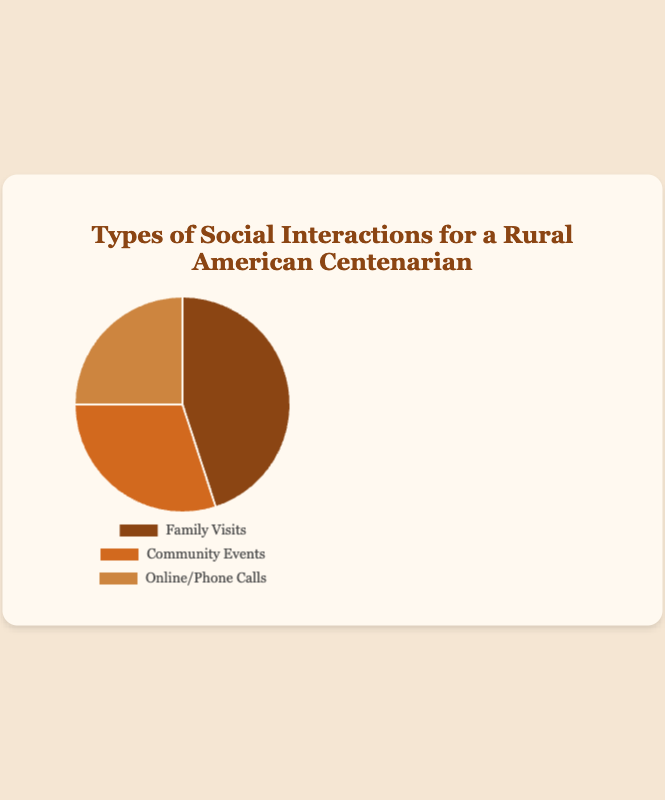Which type of social interaction has the highest percentage? Family Visits has the highest percentage. In the pie chart, Family Visits is shown with the largest segment, representing 45%.
Answer: Family Visits How much more frequent are Family Visits compared to Online/Phone Calls? Family Visits have a percentage of 45, while Online/Phone Calls have a percentage of 25. The difference between them is 45 - 25 = 20%.
Answer: 20% If we add the percentages of Community Events and Online/Phone Calls, what is the total? The percentage for Community Events is 30, and for Online/Phone Calls, it's 25. Adding these together gives 30 + 25 = 55%.
Answer: 55% Which type of social interaction is represented by the smallest section? Online/Phone Calls is represented by the smallest section of the pie, with 25%.
Answer: Online/Phone Calls Are Community Events more or less frequent than Online/Phone Calls? Community Events make up 30% while Online/Phone Calls make up 25%. Community Events are 5% more frequent.
Answer: More By how much does the percentage of Family Visits exceed the combined percentage of Community Events and Online/Phone Calls? Family Visits are 45%, and the combined percentage of Community Events and Online/Phone Calls is 55%. The difference is 45 - 55 = -10%, meaning Family Visits do not exceed but rather are 10% less.
Answer: -10% What fraction of the total social interactions are represented by Community Events? Community Events make up 30% of the total interactions. Converting this to a fraction, 30% is the same as 30/100 or 3/10.
Answer: 3/10 If the total number of social interactions is 100 (assuming percentages as absolute numbers), how many interactions are through Family Visits? If the total number of interactions is 100, and Family Visits are 45%, then the number of Family Visits is 45% of 100, which is (0.45 * 100) = 45 interactions.
Answer: 45 What is the average percentage of all three types of social interactions? The percentages are 45 for Family Visits, 30 for Community Events, and 25 for Online/Phone Calls. The average is (45 + 30 + 25) / 3 = 100 / 3 ≈ 33.33%.
Answer: 33.33% What is the ratio of Family Visits to Community Events? Family Visits have a percentage of 45, and Community Events have 30. The ratio is 45:30, which simplifies to 3:2.
Answer: 3:2 